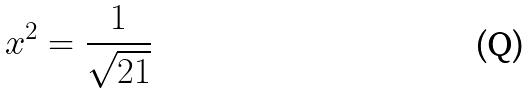<formula> <loc_0><loc_0><loc_500><loc_500>x ^ { 2 } = \frac { 1 } { \sqrt { 2 1 } }</formula> 